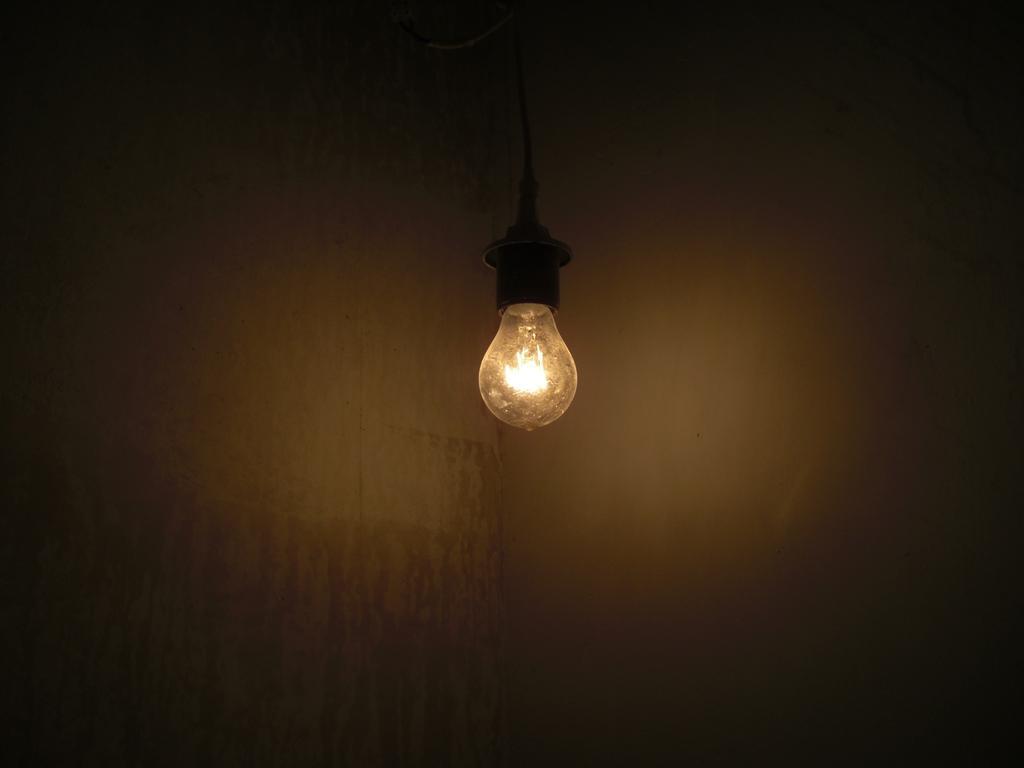Could you give a brief overview of what you see in this image? In this picture we can see an electric bulb. In the background we can see a wall. 